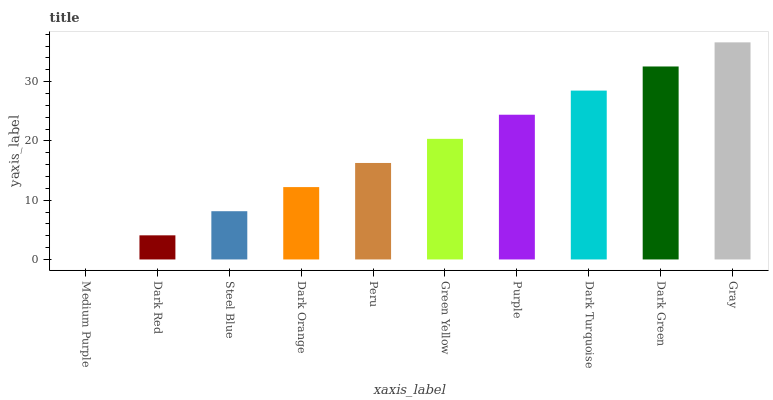Is Medium Purple the minimum?
Answer yes or no. Yes. Is Gray the maximum?
Answer yes or no. Yes. Is Dark Red the minimum?
Answer yes or no. No. Is Dark Red the maximum?
Answer yes or no. No. Is Dark Red greater than Medium Purple?
Answer yes or no. Yes. Is Medium Purple less than Dark Red?
Answer yes or no. Yes. Is Medium Purple greater than Dark Red?
Answer yes or no. No. Is Dark Red less than Medium Purple?
Answer yes or no. No. Is Green Yellow the high median?
Answer yes or no. Yes. Is Peru the low median?
Answer yes or no. Yes. Is Gray the high median?
Answer yes or no. No. Is Dark Turquoise the low median?
Answer yes or no. No. 